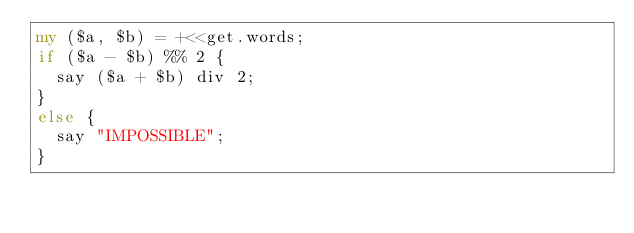<code> <loc_0><loc_0><loc_500><loc_500><_Perl_>my ($a, $b) = +<<get.words;
if ($a - $b) %% 2 {
  say ($a + $b) div 2;
}
else {
  say "IMPOSSIBLE";
}</code> 